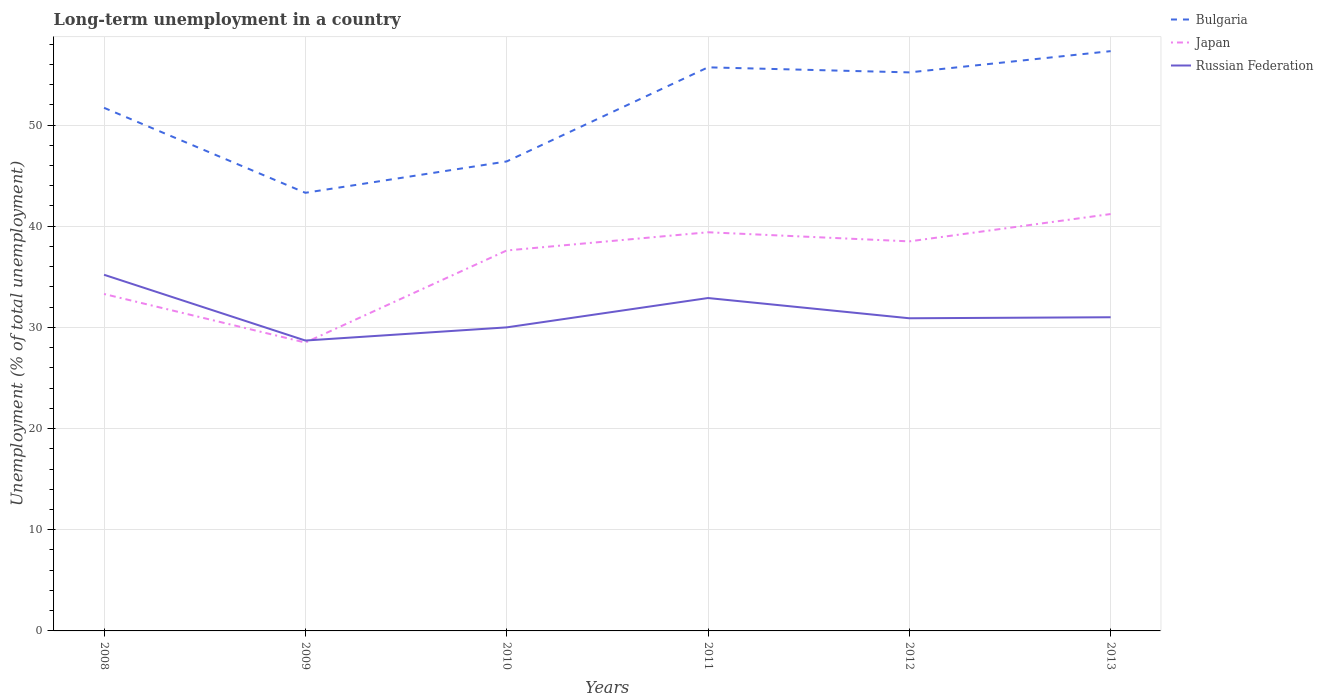How many different coloured lines are there?
Offer a terse response. 3. Across all years, what is the maximum percentage of long-term unemployed population in Russian Federation?
Keep it short and to the point. 28.7. In which year was the percentage of long-term unemployed population in Bulgaria maximum?
Offer a terse response. 2009. What is the total percentage of long-term unemployed population in Japan in the graph?
Offer a terse response. -7.9. What is the difference between the highest and the second highest percentage of long-term unemployed population in Russian Federation?
Ensure brevity in your answer.  6.5. What is the difference between the highest and the lowest percentage of long-term unemployed population in Japan?
Offer a terse response. 4. How many years are there in the graph?
Provide a succinct answer. 6. Are the values on the major ticks of Y-axis written in scientific E-notation?
Offer a terse response. No. Where does the legend appear in the graph?
Make the answer very short. Top right. How many legend labels are there?
Provide a succinct answer. 3. What is the title of the graph?
Your answer should be very brief. Long-term unemployment in a country. What is the label or title of the X-axis?
Provide a succinct answer. Years. What is the label or title of the Y-axis?
Your response must be concise. Unemployment (% of total unemployment). What is the Unemployment (% of total unemployment) in Bulgaria in 2008?
Make the answer very short. 51.7. What is the Unemployment (% of total unemployment) in Japan in 2008?
Offer a terse response. 33.3. What is the Unemployment (% of total unemployment) of Russian Federation in 2008?
Provide a short and direct response. 35.2. What is the Unemployment (% of total unemployment) in Bulgaria in 2009?
Your answer should be very brief. 43.3. What is the Unemployment (% of total unemployment) of Russian Federation in 2009?
Offer a terse response. 28.7. What is the Unemployment (% of total unemployment) in Bulgaria in 2010?
Provide a succinct answer. 46.4. What is the Unemployment (% of total unemployment) of Japan in 2010?
Your response must be concise. 37.6. What is the Unemployment (% of total unemployment) of Bulgaria in 2011?
Ensure brevity in your answer.  55.7. What is the Unemployment (% of total unemployment) of Japan in 2011?
Offer a terse response. 39.4. What is the Unemployment (% of total unemployment) of Russian Federation in 2011?
Keep it short and to the point. 32.9. What is the Unemployment (% of total unemployment) in Bulgaria in 2012?
Your response must be concise. 55.2. What is the Unemployment (% of total unemployment) of Japan in 2012?
Your response must be concise. 38.5. What is the Unemployment (% of total unemployment) of Russian Federation in 2012?
Offer a terse response. 30.9. What is the Unemployment (% of total unemployment) of Bulgaria in 2013?
Offer a terse response. 57.3. What is the Unemployment (% of total unemployment) of Japan in 2013?
Your response must be concise. 41.2. What is the Unemployment (% of total unemployment) of Russian Federation in 2013?
Offer a very short reply. 31. Across all years, what is the maximum Unemployment (% of total unemployment) in Bulgaria?
Provide a short and direct response. 57.3. Across all years, what is the maximum Unemployment (% of total unemployment) in Japan?
Provide a short and direct response. 41.2. Across all years, what is the maximum Unemployment (% of total unemployment) of Russian Federation?
Make the answer very short. 35.2. Across all years, what is the minimum Unemployment (% of total unemployment) of Bulgaria?
Your response must be concise. 43.3. Across all years, what is the minimum Unemployment (% of total unemployment) in Japan?
Ensure brevity in your answer.  28.5. Across all years, what is the minimum Unemployment (% of total unemployment) of Russian Federation?
Make the answer very short. 28.7. What is the total Unemployment (% of total unemployment) in Bulgaria in the graph?
Provide a short and direct response. 309.6. What is the total Unemployment (% of total unemployment) in Japan in the graph?
Your response must be concise. 218.5. What is the total Unemployment (% of total unemployment) in Russian Federation in the graph?
Make the answer very short. 188.7. What is the difference between the Unemployment (% of total unemployment) in Japan in 2008 and that in 2009?
Your answer should be compact. 4.8. What is the difference between the Unemployment (% of total unemployment) of Bulgaria in 2008 and that in 2010?
Give a very brief answer. 5.3. What is the difference between the Unemployment (% of total unemployment) in Japan in 2008 and that in 2010?
Provide a succinct answer. -4.3. What is the difference between the Unemployment (% of total unemployment) in Russian Federation in 2008 and that in 2010?
Your answer should be compact. 5.2. What is the difference between the Unemployment (% of total unemployment) of Bulgaria in 2008 and that in 2012?
Make the answer very short. -3.5. What is the difference between the Unemployment (% of total unemployment) in Russian Federation in 2009 and that in 2010?
Provide a short and direct response. -1.3. What is the difference between the Unemployment (% of total unemployment) in Bulgaria in 2009 and that in 2011?
Provide a short and direct response. -12.4. What is the difference between the Unemployment (% of total unemployment) in Japan in 2009 and that in 2011?
Your response must be concise. -10.9. What is the difference between the Unemployment (% of total unemployment) in Russian Federation in 2009 and that in 2011?
Keep it short and to the point. -4.2. What is the difference between the Unemployment (% of total unemployment) in Japan in 2009 and that in 2012?
Your response must be concise. -10. What is the difference between the Unemployment (% of total unemployment) of Bulgaria in 2009 and that in 2013?
Your response must be concise. -14. What is the difference between the Unemployment (% of total unemployment) of Japan in 2010 and that in 2011?
Provide a succinct answer. -1.8. What is the difference between the Unemployment (% of total unemployment) in Bulgaria in 2010 and that in 2013?
Your answer should be very brief. -10.9. What is the difference between the Unemployment (% of total unemployment) in Russian Federation in 2010 and that in 2013?
Offer a terse response. -1. What is the difference between the Unemployment (% of total unemployment) in Russian Federation in 2011 and that in 2013?
Give a very brief answer. 1.9. What is the difference between the Unemployment (% of total unemployment) of Bulgaria in 2012 and that in 2013?
Provide a short and direct response. -2.1. What is the difference between the Unemployment (% of total unemployment) in Japan in 2012 and that in 2013?
Provide a short and direct response. -2.7. What is the difference between the Unemployment (% of total unemployment) of Russian Federation in 2012 and that in 2013?
Make the answer very short. -0.1. What is the difference between the Unemployment (% of total unemployment) of Bulgaria in 2008 and the Unemployment (% of total unemployment) of Japan in 2009?
Keep it short and to the point. 23.2. What is the difference between the Unemployment (% of total unemployment) of Bulgaria in 2008 and the Unemployment (% of total unemployment) of Russian Federation in 2009?
Your answer should be very brief. 23. What is the difference between the Unemployment (% of total unemployment) in Japan in 2008 and the Unemployment (% of total unemployment) in Russian Federation in 2009?
Provide a short and direct response. 4.6. What is the difference between the Unemployment (% of total unemployment) in Bulgaria in 2008 and the Unemployment (% of total unemployment) in Japan in 2010?
Ensure brevity in your answer.  14.1. What is the difference between the Unemployment (% of total unemployment) of Bulgaria in 2008 and the Unemployment (% of total unemployment) of Russian Federation in 2010?
Your response must be concise. 21.7. What is the difference between the Unemployment (% of total unemployment) in Japan in 2008 and the Unemployment (% of total unemployment) in Russian Federation in 2011?
Your response must be concise. 0.4. What is the difference between the Unemployment (% of total unemployment) of Bulgaria in 2008 and the Unemployment (% of total unemployment) of Russian Federation in 2012?
Offer a very short reply. 20.8. What is the difference between the Unemployment (% of total unemployment) in Bulgaria in 2008 and the Unemployment (% of total unemployment) in Japan in 2013?
Provide a short and direct response. 10.5. What is the difference between the Unemployment (% of total unemployment) of Bulgaria in 2008 and the Unemployment (% of total unemployment) of Russian Federation in 2013?
Keep it short and to the point. 20.7. What is the difference between the Unemployment (% of total unemployment) of Bulgaria in 2009 and the Unemployment (% of total unemployment) of Russian Federation in 2011?
Ensure brevity in your answer.  10.4. What is the difference between the Unemployment (% of total unemployment) of Japan in 2009 and the Unemployment (% of total unemployment) of Russian Federation in 2011?
Ensure brevity in your answer.  -4.4. What is the difference between the Unemployment (% of total unemployment) of Japan in 2009 and the Unemployment (% of total unemployment) of Russian Federation in 2012?
Your answer should be compact. -2.4. What is the difference between the Unemployment (% of total unemployment) in Japan in 2009 and the Unemployment (% of total unemployment) in Russian Federation in 2013?
Give a very brief answer. -2.5. What is the difference between the Unemployment (% of total unemployment) of Bulgaria in 2010 and the Unemployment (% of total unemployment) of Japan in 2012?
Your answer should be compact. 7.9. What is the difference between the Unemployment (% of total unemployment) in Bulgaria in 2010 and the Unemployment (% of total unemployment) in Russian Federation in 2012?
Offer a very short reply. 15.5. What is the difference between the Unemployment (% of total unemployment) of Japan in 2010 and the Unemployment (% of total unemployment) of Russian Federation in 2012?
Keep it short and to the point. 6.7. What is the difference between the Unemployment (% of total unemployment) of Bulgaria in 2010 and the Unemployment (% of total unemployment) of Japan in 2013?
Give a very brief answer. 5.2. What is the difference between the Unemployment (% of total unemployment) of Japan in 2010 and the Unemployment (% of total unemployment) of Russian Federation in 2013?
Your answer should be compact. 6.6. What is the difference between the Unemployment (% of total unemployment) in Bulgaria in 2011 and the Unemployment (% of total unemployment) in Russian Federation in 2012?
Offer a terse response. 24.8. What is the difference between the Unemployment (% of total unemployment) of Bulgaria in 2011 and the Unemployment (% of total unemployment) of Japan in 2013?
Ensure brevity in your answer.  14.5. What is the difference between the Unemployment (% of total unemployment) of Bulgaria in 2011 and the Unemployment (% of total unemployment) of Russian Federation in 2013?
Give a very brief answer. 24.7. What is the difference between the Unemployment (% of total unemployment) in Japan in 2011 and the Unemployment (% of total unemployment) in Russian Federation in 2013?
Ensure brevity in your answer.  8.4. What is the difference between the Unemployment (% of total unemployment) in Bulgaria in 2012 and the Unemployment (% of total unemployment) in Japan in 2013?
Your answer should be compact. 14. What is the difference between the Unemployment (% of total unemployment) in Bulgaria in 2012 and the Unemployment (% of total unemployment) in Russian Federation in 2013?
Keep it short and to the point. 24.2. What is the average Unemployment (% of total unemployment) of Bulgaria per year?
Provide a short and direct response. 51.6. What is the average Unemployment (% of total unemployment) of Japan per year?
Your answer should be compact. 36.42. What is the average Unemployment (% of total unemployment) of Russian Federation per year?
Ensure brevity in your answer.  31.45. In the year 2008, what is the difference between the Unemployment (% of total unemployment) in Bulgaria and Unemployment (% of total unemployment) in Russian Federation?
Ensure brevity in your answer.  16.5. In the year 2009, what is the difference between the Unemployment (% of total unemployment) in Bulgaria and Unemployment (% of total unemployment) in Japan?
Your response must be concise. 14.8. In the year 2009, what is the difference between the Unemployment (% of total unemployment) of Japan and Unemployment (% of total unemployment) of Russian Federation?
Offer a very short reply. -0.2. In the year 2011, what is the difference between the Unemployment (% of total unemployment) in Bulgaria and Unemployment (% of total unemployment) in Russian Federation?
Provide a succinct answer. 22.8. In the year 2011, what is the difference between the Unemployment (% of total unemployment) of Japan and Unemployment (% of total unemployment) of Russian Federation?
Your answer should be very brief. 6.5. In the year 2012, what is the difference between the Unemployment (% of total unemployment) of Bulgaria and Unemployment (% of total unemployment) of Russian Federation?
Make the answer very short. 24.3. In the year 2012, what is the difference between the Unemployment (% of total unemployment) of Japan and Unemployment (% of total unemployment) of Russian Federation?
Provide a succinct answer. 7.6. In the year 2013, what is the difference between the Unemployment (% of total unemployment) of Bulgaria and Unemployment (% of total unemployment) of Japan?
Your response must be concise. 16.1. In the year 2013, what is the difference between the Unemployment (% of total unemployment) of Bulgaria and Unemployment (% of total unemployment) of Russian Federation?
Provide a short and direct response. 26.3. In the year 2013, what is the difference between the Unemployment (% of total unemployment) in Japan and Unemployment (% of total unemployment) in Russian Federation?
Provide a short and direct response. 10.2. What is the ratio of the Unemployment (% of total unemployment) of Bulgaria in 2008 to that in 2009?
Ensure brevity in your answer.  1.19. What is the ratio of the Unemployment (% of total unemployment) of Japan in 2008 to that in 2009?
Keep it short and to the point. 1.17. What is the ratio of the Unemployment (% of total unemployment) of Russian Federation in 2008 to that in 2009?
Offer a terse response. 1.23. What is the ratio of the Unemployment (% of total unemployment) in Bulgaria in 2008 to that in 2010?
Your answer should be very brief. 1.11. What is the ratio of the Unemployment (% of total unemployment) of Japan in 2008 to that in 2010?
Provide a succinct answer. 0.89. What is the ratio of the Unemployment (% of total unemployment) of Russian Federation in 2008 to that in 2010?
Make the answer very short. 1.17. What is the ratio of the Unemployment (% of total unemployment) in Bulgaria in 2008 to that in 2011?
Your answer should be compact. 0.93. What is the ratio of the Unemployment (% of total unemployment) of Japan in 2008 to that in 2011?
Ensure brevity in your answer.  0.85. What is the ratio of the Unemployment (% of total unemployment) of Russian Federation in 2008 to that in 2011?
Give a very brief answer. 1.07. What is the ratio of the Unemployment (% of total unemployment) in Bulgaria in 2008 to that in 2012?
Provide a short and direct response. 0.94. What is the ratio of the Unemployment (% of total unemployment) of Japan in 2008 to that in 2012?
Offer a terse response. 0.86. What is the ratio of the Unemployment (% of total unemployment) of Russian Federation in 2008 to that in 2012?
Provide a short and direct response. 1.14. What is the ratio of the Unemployment (% of total unemployment) in Bulgaria in 2008 to that in 2013?
Your response must be concise. 0.9. What is the ratio of the Unemployment (% of total unemployment) in Japan in 2008 to that in 2013?
Provide a succinct answer. 0.81. What is the ratio of the Unemployment (% of total unemployment) of Russian Federation in 2008 to that in 2013?
Your response must be concise. 1.14. What is the ratio of the Unemployment (% of total unemployment) of Bulgaria in 2009 to that in 2010?
Make the answer very short. 0.93. What is the ratio of the Unemployment (% of total unemployment) of Japan in 2009 to that in 2010?
Offer a very short reply. 0.76. What is the ratio of the Unemployment (% of total unemployment) of Russian Federation in 2009 to that in 2010?
Give a very brief answer. 0.96. What is the ratio of the Unemployment (% of total unemployment) in Bulgaria in 2009 to that in 2011?
Provide a short and direct response. 0.78. What is the ratio of the Unemployment (% of total unemployment) of Japan in 2009 to that in 2011?
Offer a terse response. 0.72. What is the ratio of the Unemployment (% of total unemployment) of Russian Federation in 2009 to that in 2011?
Make the answer very short. 0.87. What is the ratio of the Unemployment (% of total unemployment) of Bulgaria in 2009 to that in 2012?
Keep it short and to the point. 0.78. What is the ratio of the Unemployment (% of total unemployment) in Japan in 2009 to that in 2012?
Offer a terse response. 0.74. What is the ratio of the Unemployment (% of total unemployment) of Russian Federation in 2009 to that in 2012?
Provide a short and direct response. 0.93. What is the ratio of the Unemployment (% of total unemployment) of Bulgaria in 2009 to that in 2013?
Your response must be concise. 0.76. What is the ratio of the Unemployment (% of total unemployment) in Japan in 2009 to that in 2013?
Your answer should be compact. 0.69. What is the ratio of the Unemployment (% of total unemployment) of Russian Federation in 2009 to that in 2013?
Give a very brief answer. 0.93. What is the ratio of the Unemployment (% of total unemployment) of Bulgaria in 2010 to that in 2011?
Give a very brief answer. 0.83. What is the ratio of the Unemployment (% of total unemployment) in Japan in 2010 to that in 2011?
Provide a short and direct response. 0.95. What is the ratio of the Unemployment (% of total unemployment) in Russian Federation in 2010 to that in 2011?
Provide a short and direct response. 0.91. What is the ratio of the Unemployment (% of total unemployment) in Bulgaria in 2010 to that in 2012?
Give a very brief answer. 0.84. What is the ratio of the Unemployment (% of total unemployment) in Japan in 2010 to that in 2012?
Offer a very short reply. 0.98. What is the ratio of the Unemployment (% of total unemployment) in Russian Federation in 2010 to that in 2012?
Provide a short and direct response. 0.97. What is the ratio of the Unemployment (% of total unemployment) of Bulgaria in 2010 to that in 2013?
Make the answer very short. 0.81. What is the ratio of the Unemployment (% of total unemployment) in Japan in 2010 to that in 2013?
Provide a short and direct response. 0.91. What is the ratio of the Unemployment (% of total unemployment) of Bulgaria in 2011 to that in 2012?
Your answer should be compact. 1.01. What is the ratio of the Unemployment (% of total unemployment) in Japan in 2011 to that in 2012?
Provide a short and direct response. 1.02. What is the ratio of the Unemployment (% of total unemployment) in Russian Federation in 2011 to that in 2012?
Your answer should be compact. 1.06. What is the ratio of the Unemployment (% of total unemployment) in Bulgaria in 2011 to that in 2013?
Give a very brief answer. 0.97. What is the ratio of the Unemployment (% of total unemployment) of Japan in 2011 to that in 2013?
Your answer should be very brief. 0.96. What is the ratio of the Unemployment (% of total unemployment) of Russian Federation in 2011 to that in 2013?
Make the answer very short. 1.06. What is the ratio of the Unemployment (% of total unemployment) in Bulgaria in 2012 to that in 2013?
Your answer should be compact. 0.96. What is the ratio of the Unemployment (% of total unemployment) of Japan in 2012 to that in 2013?
Keep it short and to the point. 0.93. What is the difference between the highest and the second highest Unemployment (% of total unemployment) of Bulgaria?
Provide a succinct answer. 1.6. What is the difference between the highest and the second highest Unemployment (% of total unemployment) of Japan?
Keep it short and to the point. 1.8. What is the difference between the highest and the lowest Unemployment (% of total unemployment) of Russian Federation?
Make the answer very short. 6.5. 